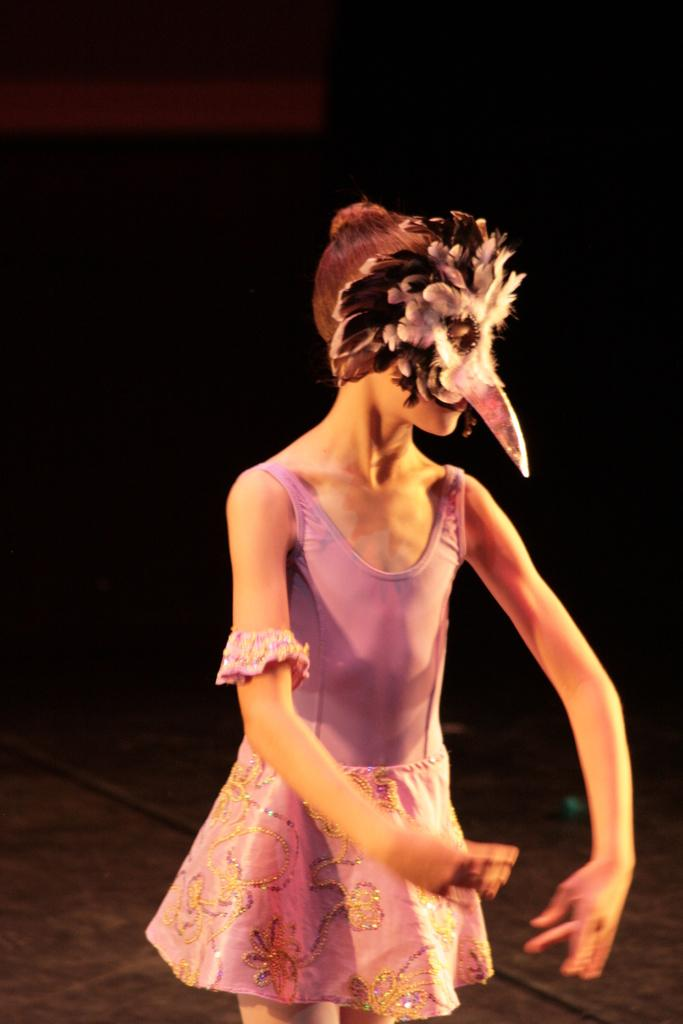Who is present in the image? There is a woman in the image. What is the woman wearing on her face? The woman is wearing a mask. What type of clouds can be seen in the image? There are no clouds visible in the image, as it only features a woman wearing a mask. What kind of iron object is being used by the bear in the image? There is no bear or iron object present in the image. 